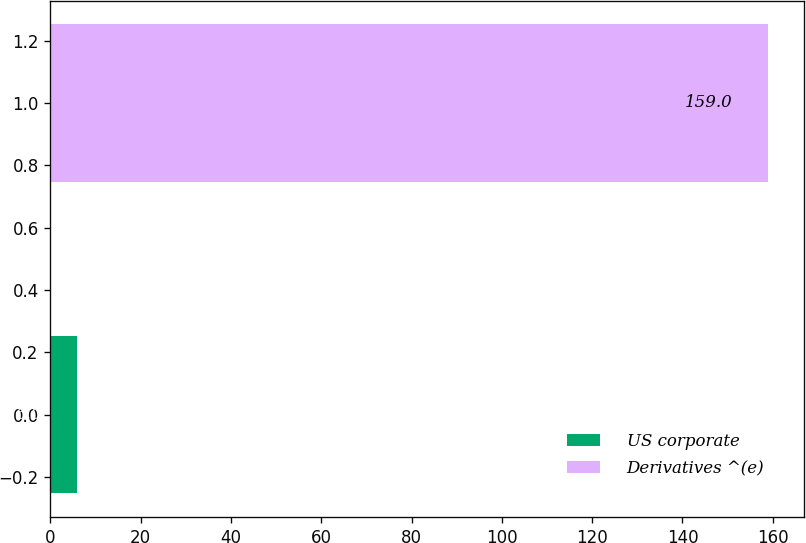Convert chart. <chart><loc_0><loc_0><loc_500><loc_500><bar_chart><fcel>US corporate<fcel>Derivatives ^(e)<nl><fcel>6<fcel>159<nl></chart> 